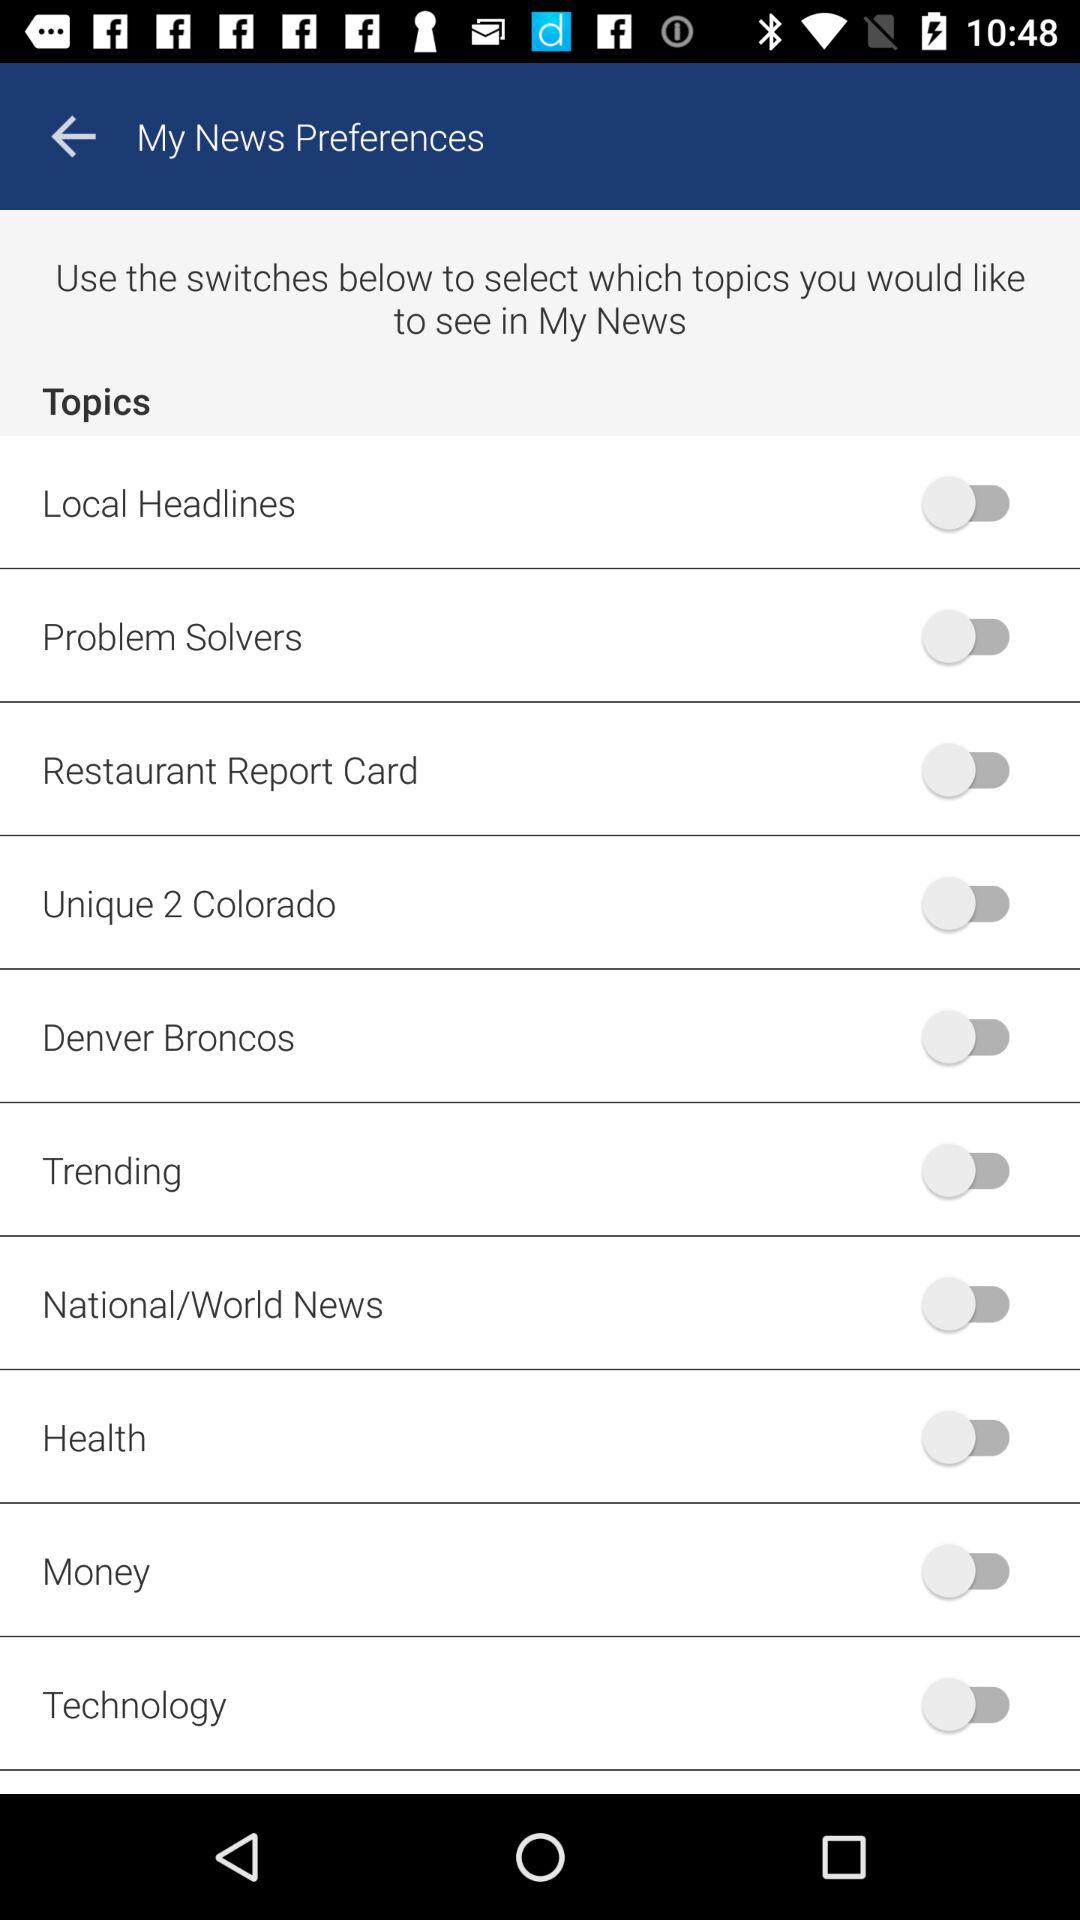What is the status of "Money"? The status of "Money" is "off". 